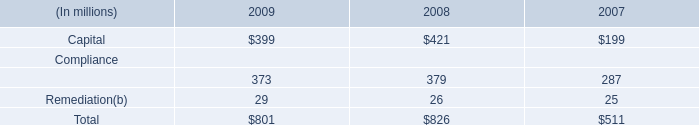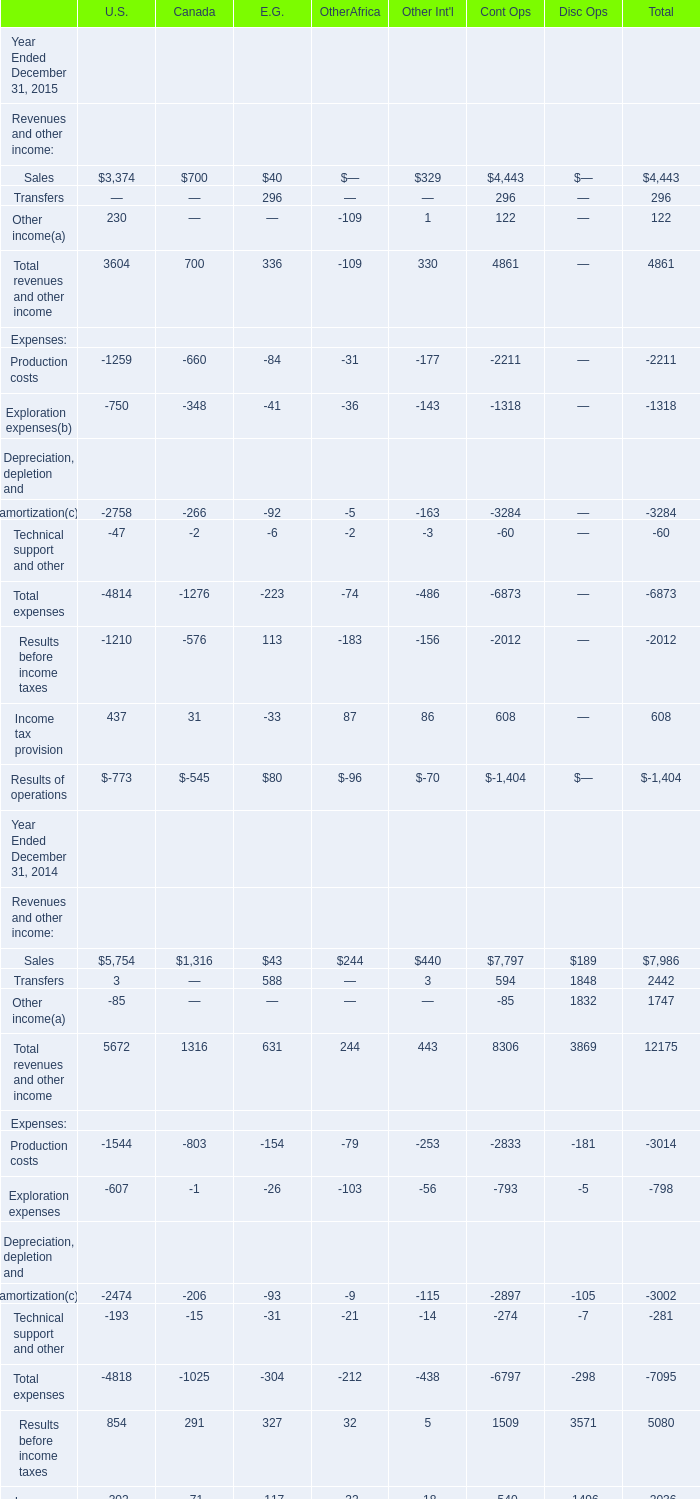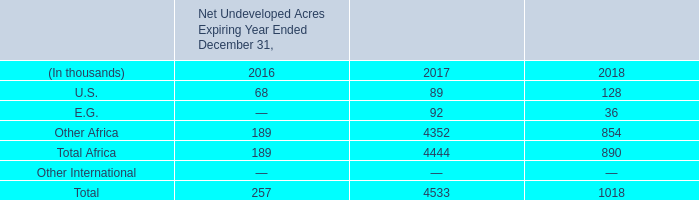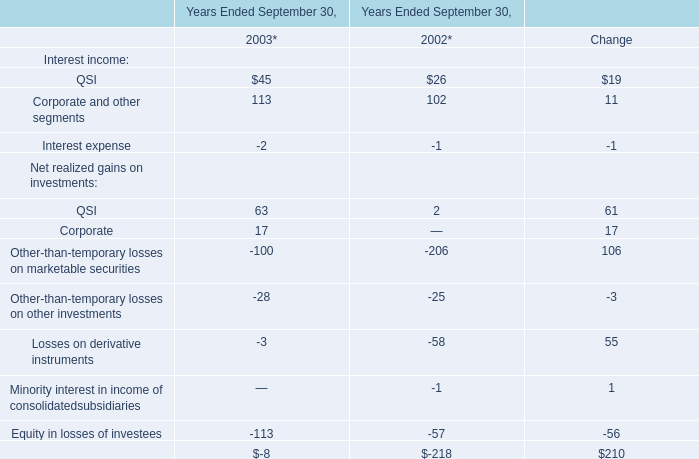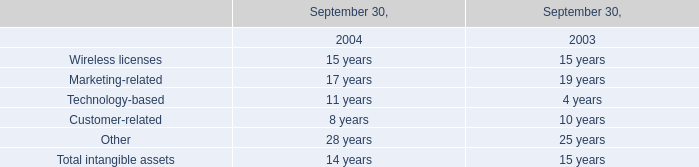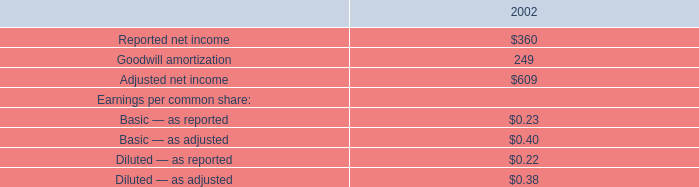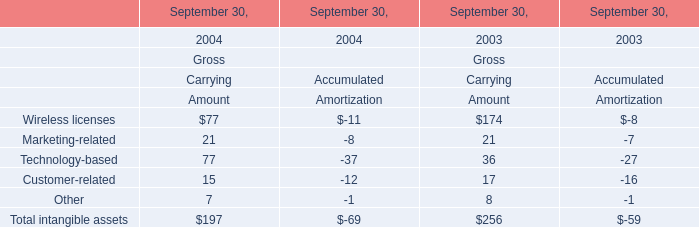What is the growing rate of Technology-based in the years with the least Wireless licenses? 
Computations: (((77 - 37) - (36 - 27)) / (77 - 37))
Answer: 0.775. 